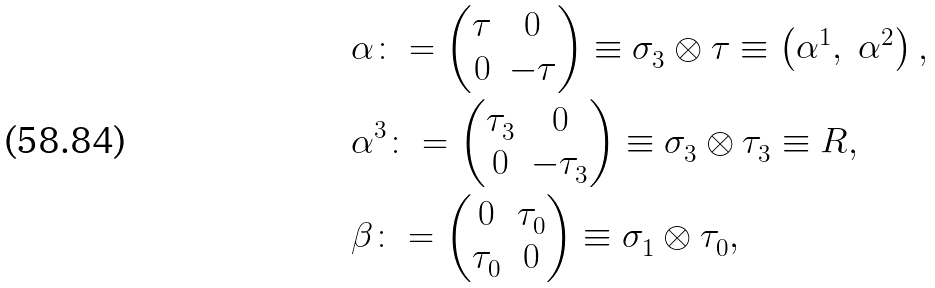<formula> <loc_0><loc_0><loc_500><loc_500>& \alpha \colon = \begin{pmatrix} \tau & 0 \\ 0 & - \tau \end{pmatrix} \equiv \sigma ^ { \ } _ { 3 } \otimes \tau \equiv \begin{pmatrix} \alpha ^ { 1 } , & \alpha ^ { 2 } \end{pmatrix} , \\ & \alpha ^ { 3 } \colon = \begin{pmatrix} \tau ^ { \ } _ { 3 } & 0 \\ 0 & - \tau ^ { \ } _ { 3 } \end{pmatrix} \equiv \sigma ^ { \ } _ { 3 } \otimes \tau ^ { \ } _ { 3 } \equiv R , \\ & \beta \colon = \begin{pmatrix} 0 & \tau ^ { \ } _ { 0 } \\ \tau ^ { \ } _ { 0 } & 0 \end{pmatrix} \equiv \sigma ^ { \ } _ { 1 } \otimes \tau ^ { \ } _ { 0 } ,</formula> 